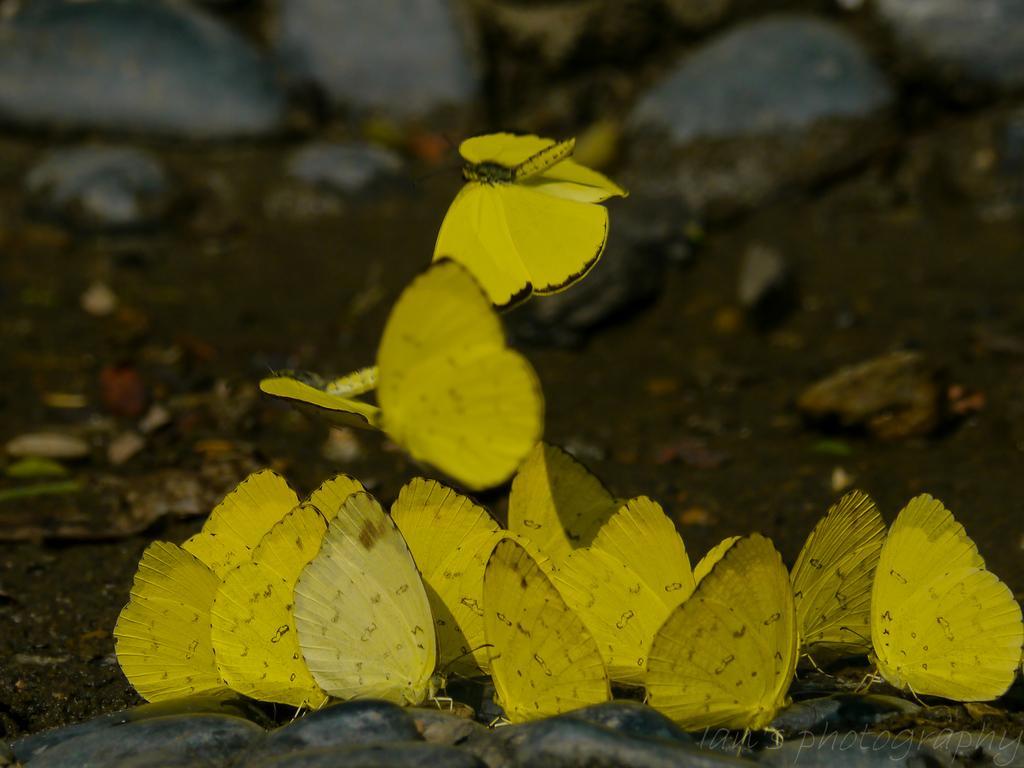Please provide a concise description of this image. In this picture there are yellow color butterflies standing on the stones and there are two butterflies flying. At the bottom there is mud and there are stones. At the bottom right there is a text. 